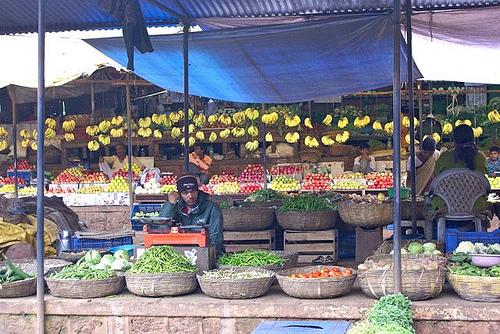Is this a market?
Keep it brief. Yes. Is the produce for sale?
Write a very short answer. Yes. Where is this?
Concise answer only. Market. 